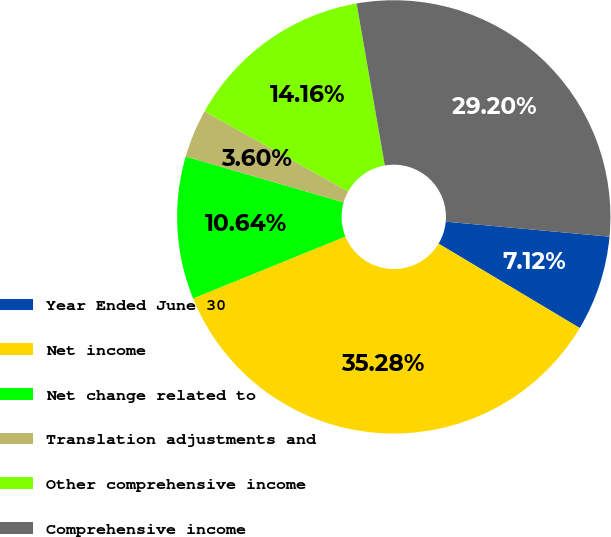Convert chart to OTSL. <chart><loc_0><loc_0><loc_500><loc_500><pie_chart><fcel>Year Ended June 30<fcel>Net income<fcel>Net change related to<fcel>Translation adjustments and<fcel>Other comprehensive income<fcel>Comprehensive income<nl><fcel>7.12%<fcel>35.28%<fcel>10.64%<fcel>3.6%<fcel>14.16%<fcel>29.2%<nl></chart> 